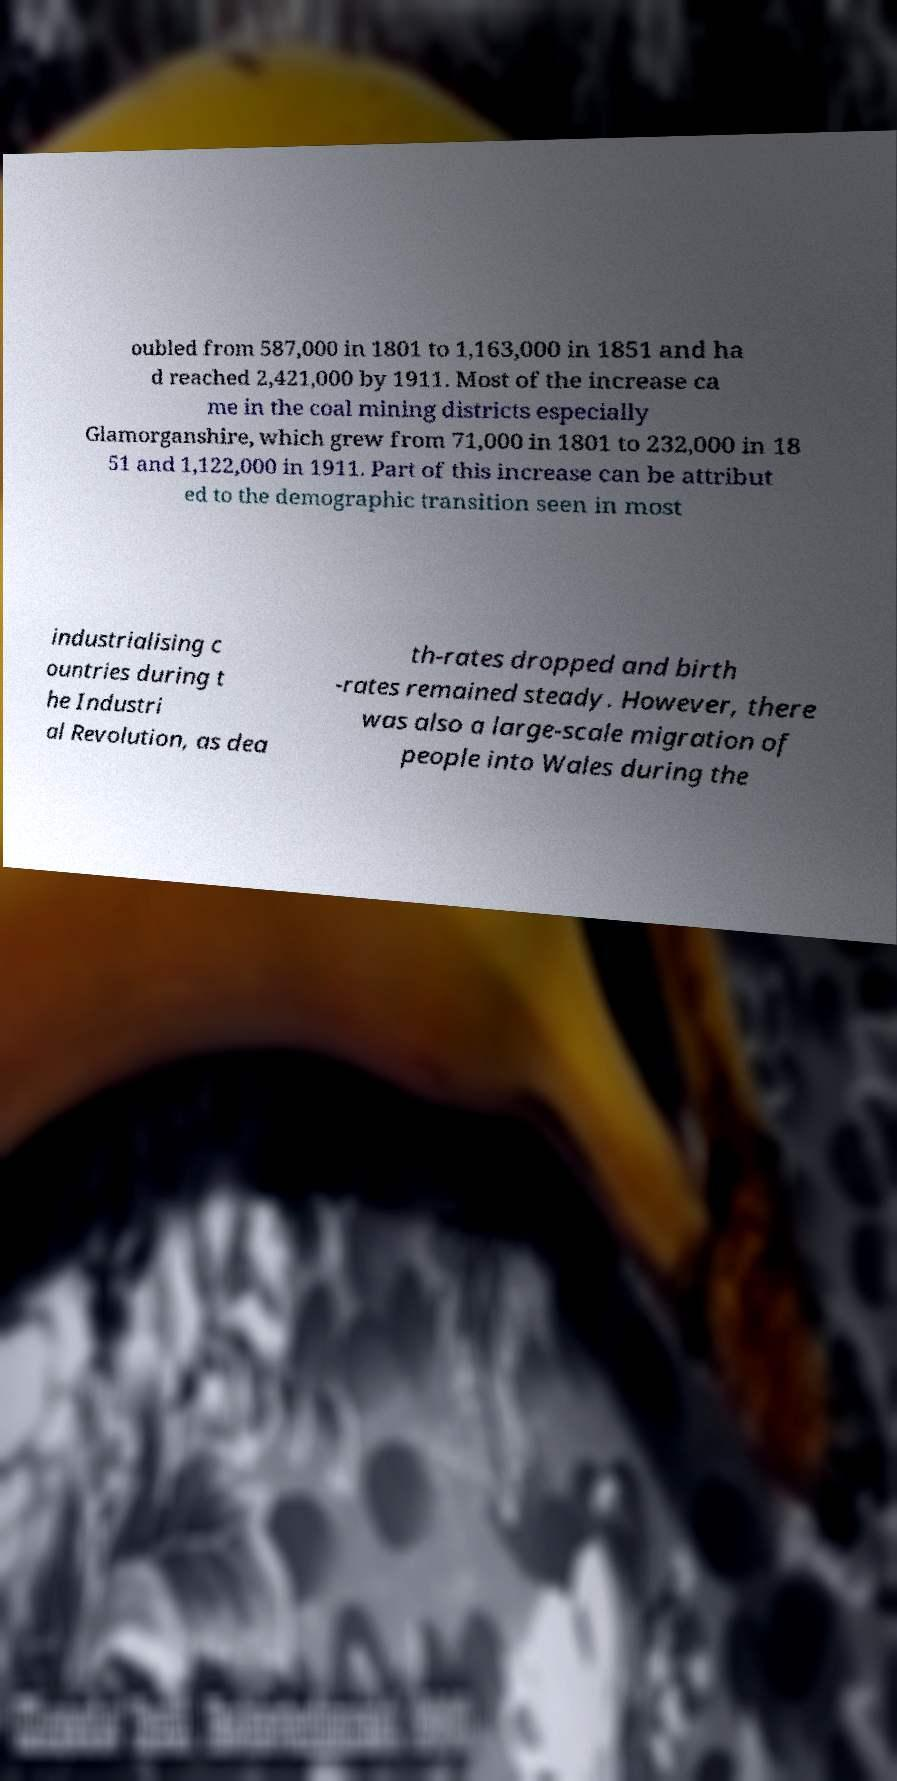What messages or text are displayed in this image? I need them in a readable, typed format. oubled from 587,000 in 1801 to 1,163,000 in 1851 and ha d reached 2,421,000 by 1911. Most of the increase ca me in the coal mining districts especially Glamorganshire, which grew from 71,000 in 1801 to 232,000 in 18 51 and 1,122,000 in 1911. Part of this increase can be attribut ed to the demographic transition seen in most industrialising c ountries during t he Industri al Revolution, as dea th-rates dropped and birth -rates remained steady. However, there was also a large-scale migration of people into Wales during the 